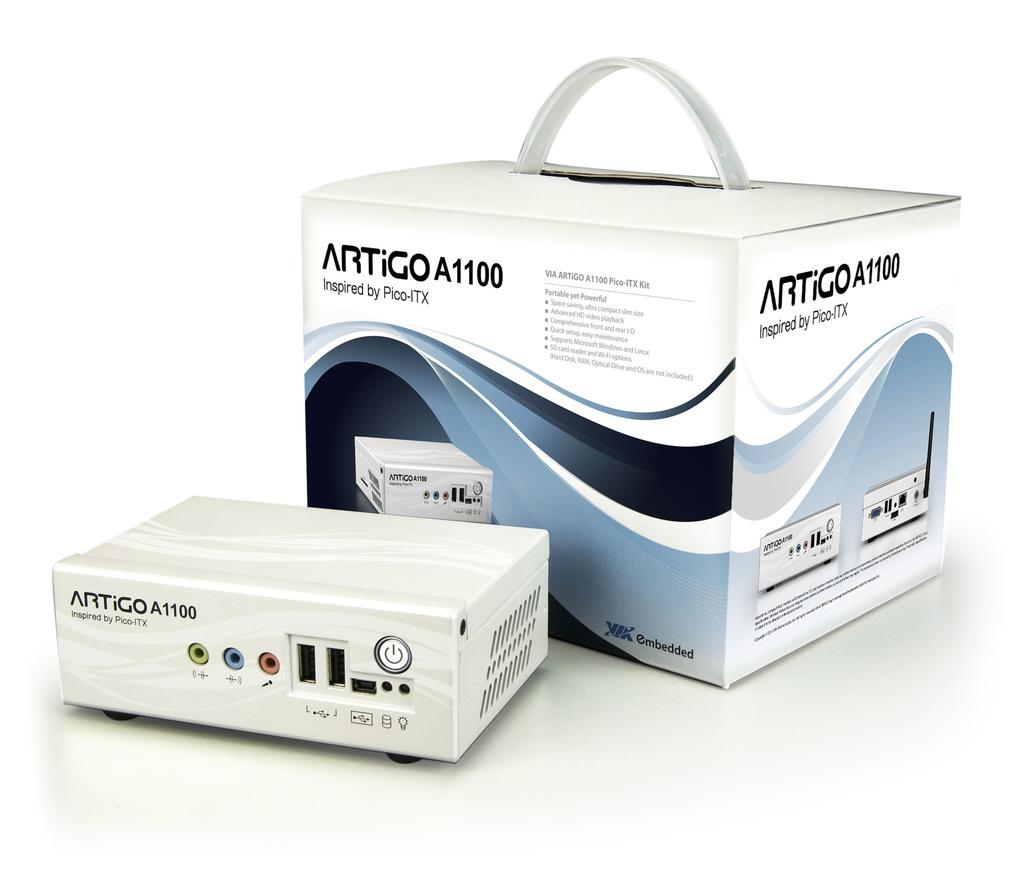<image>
Create a compact narrative representing the image presented. a box that is marked artigo A1100 next to the machine 